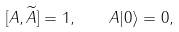<formula> <loc_0><loc_0><loc_500><loc_500>[ A , \widetilde { A } ] = 1 , \quad A | 0 \rangle = 0 ,</formula> 